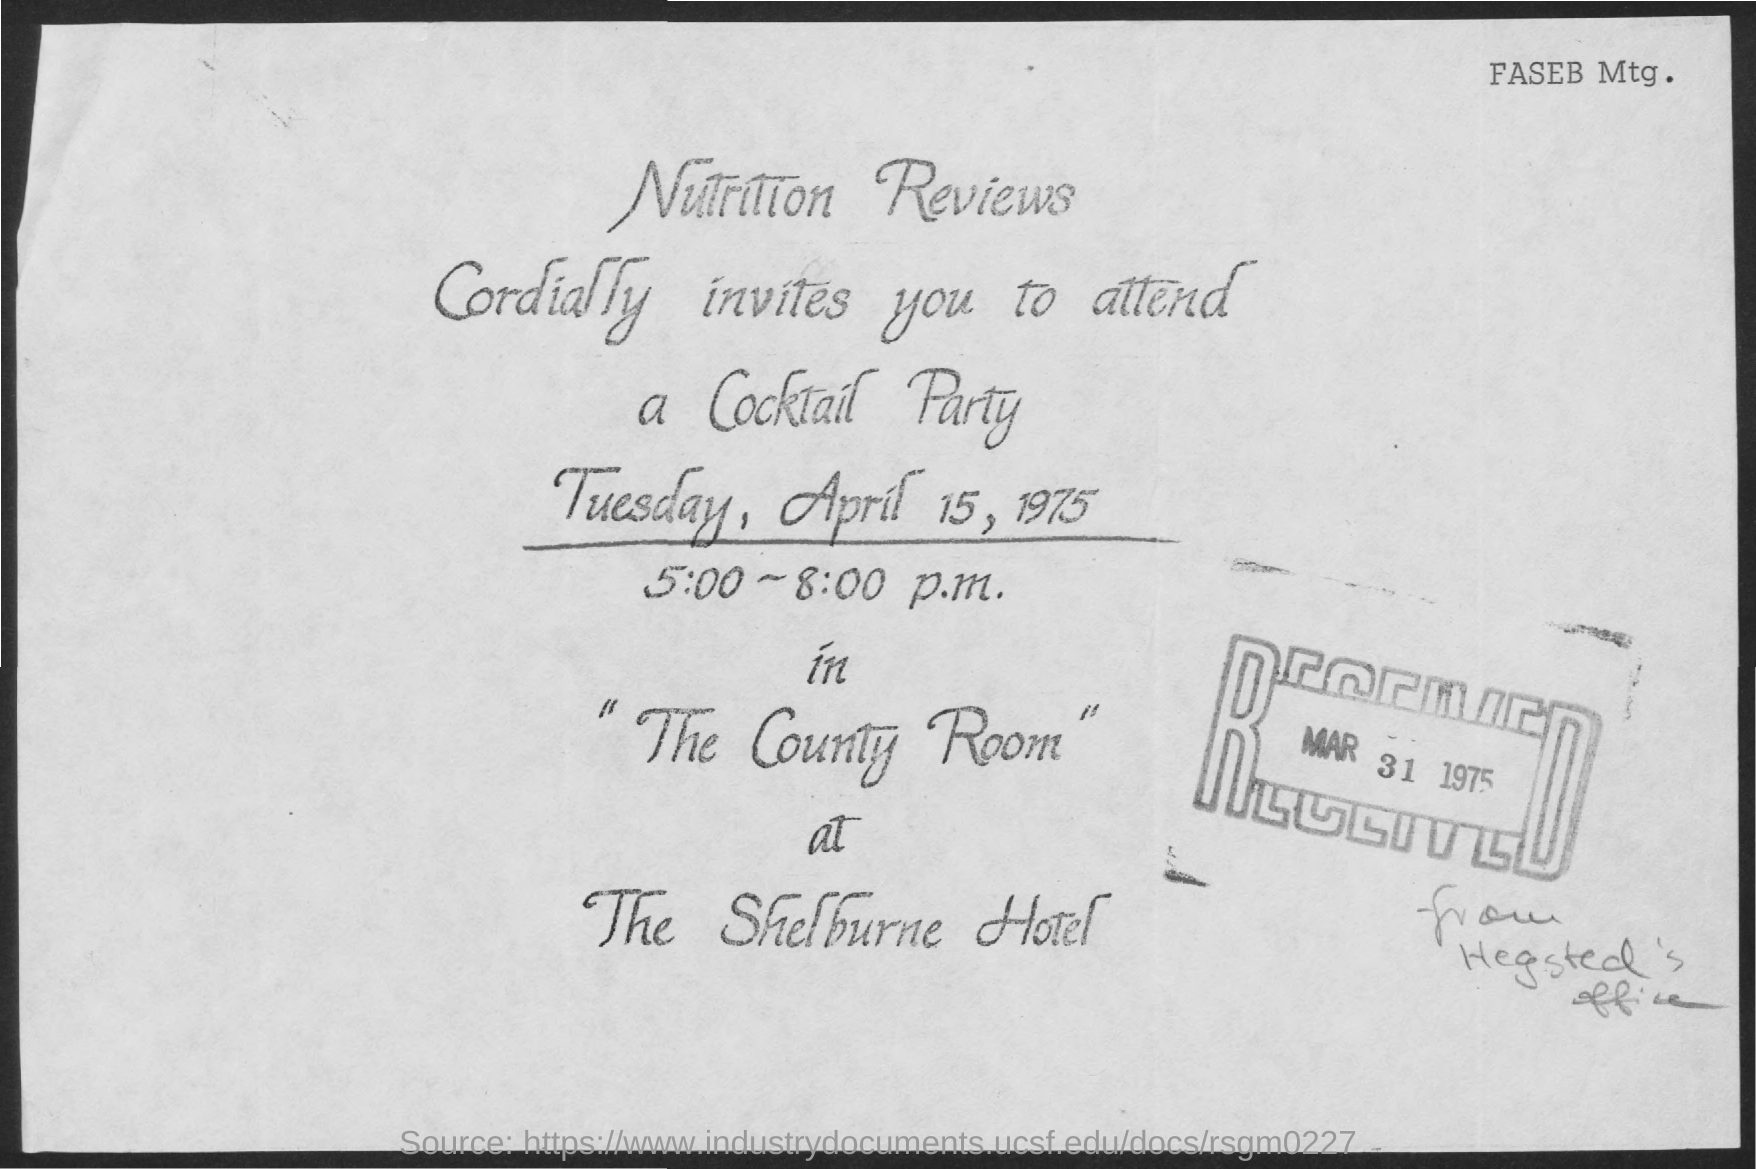What is the received date mentioned ?
Make the answer very short. Mar 31, 1975. What is the name of the room mentioned ?
Provide a succinct answer. The County Room. What is the name of the hotel mentioned ?
Your response must be concise. The shelburne hotel. What is the name of the party mentioned ?
Keep it short and to the point. Cocktail Party. What is the time mentioned in the given form ?
Keep it short and to the point. 5:00 - 8:00 p.m. 